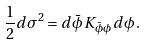Convert formula to latex. <formula><loc_0><loc_0><loc_500><loc_500>\frac { 1 } { 2 } d \sigma ^ { 2 } = d \bar { \phi } \, K _ { \bar { \phi } \phi } \, d \phi \, .</formula> 